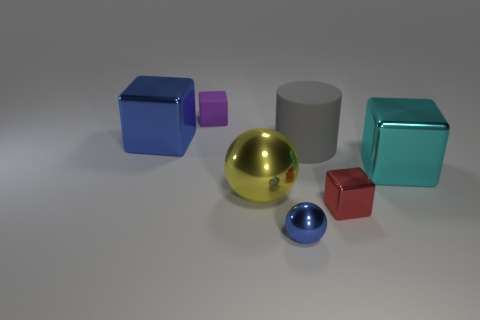There is a block that is the same color as the small ball; what is its size?
Provide a short and direct response. Large. How many other things are the same size as the gray matte cylinder?
Provide a succinct answer. 3. There is a matte cylinder; is it the same color as the shiny thing behind the cyan shiny block?
Your answer should be very brief. No. Is the number of large cyan blocks left of the purple thing less than the number of large gray objects that are on the right side of the gray rubber object?
Keep it short and to the point. No. What color is the shiny object that is behind the big yellow object and left of the small red metallic cube?
Your answer should be compact. Blue. Is the size of the yellow metal ball the same as the object that is left of the purple matte cube?
Your answer should be compact. Yes. What is the shape of the blue thing on the left side of the yellow metal thing?
Your response must be concise. Cube. Is there any other thing that is made of the same material as the cylinder?
Offer a terse response. Yes. Is the number of blue cubes behind the big blue metal block greater than the number of large cylinders?
Ensure brevity in your answer.  No. What number of big metallic blocks are to the left of the rubber thing in front of the big metallic block that is to the left of the tiny purple matte object?
Offer a very short reply. 1. 